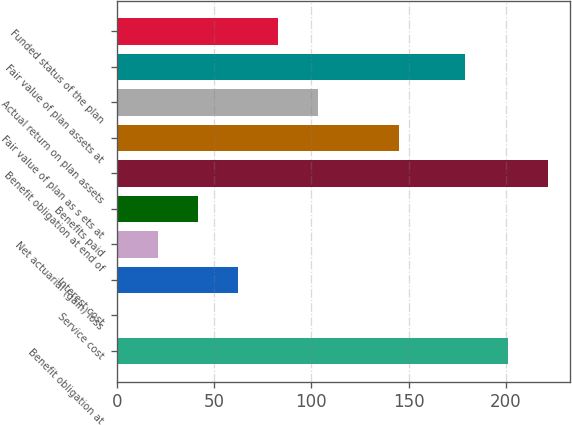Convert chart to OTSL. <chart><loc_0><loc_0><loc_500><loc_500><bar_chart><fcel>Benefit obligation at<fcel>Service cost<fcel>Interest cost<fcel>Net actuarial (gain) loss<fcel>Benefits paid<fcel>Benefit obligation at end of<fcel>Fair value of plan as s ets at<fcel>Actual return on plan assets<fcel>Fair value of plan assets at<fcel>Funded status of the plan<nl><fcel>201.1<fcel>0.4<fcel>62.29<fcel>21.03<fcel>41.66<fcel>221.73<fcel>145<fcel>103.55<fcel>179.2<fcel>82.92<nl></chart> 